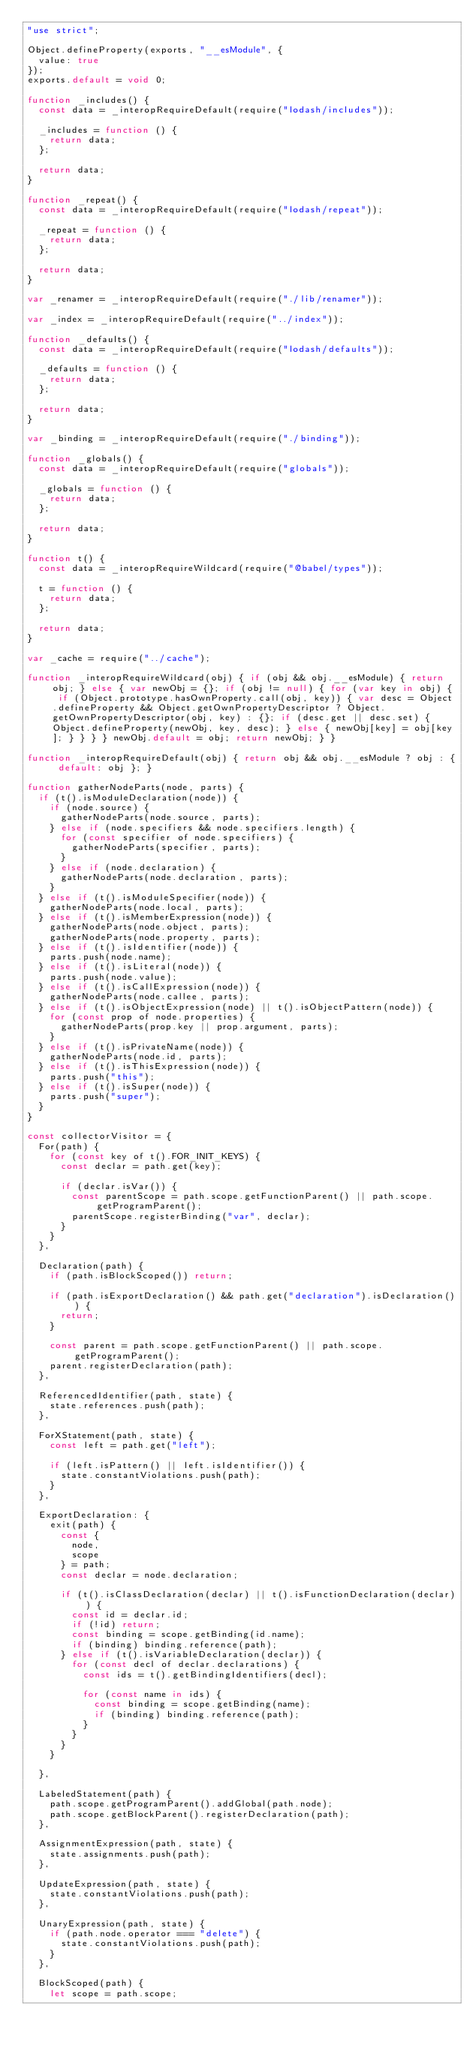Convert code to text. <code><loc_0><loc_0><loc_500><loc_500><_JavaScript_>"use strict";

Object.defineProperty(exports, "__esModule", {
  value: true
});
exports.default = void 0;

function _includes() {
  const data = _interopRequireDefault(require("lodash/includes"));

  _includes = function () {
    return data;
  };

  return data;
}

function _repeat() {
  const data = _interopRequireDefault(require("lodash/repeat"));

  _repeat = function () {
    return data;
  };

  return data;
}

var _renamer = _interopRequireDefault(require("./lib/renamer"));

var _index = _interopRequireDefault(require("../index"));

function _defaults() {
  const data = _interopRequireDefault(require("lodash/defaults"));

  _defaults = function () {
    return data;
  };

  return data;
}

var _binding = _interopRequireDefault(require("./binding"));

function _globals() {
  const data = _interopRequireDefault(require("globals"));

  _globals = function () {
    return data;
  };

  return data;
}

function t() {
  const data = _interopRequireWildcard(require("@babel/types"));

  t = function () {
    return data;
  };

  return data;
}

var _cache = require("../cache");

function _interopRequireWildcard(obj) { if (obj && obj.__esModule) { return obj; } else { var newObj = {}; if (obj != null) { for (var key in obj) { if (Object.prototype.hasOwnProperty.call(obj, key)) { var desc = Object.defineProperty && Object.getOwnPropertyDescriptor ? Object.getOwnPropertyDescriptor(obj, key) : {}; if (desc.get || desc.set) { Object.defineProperty(newObj, key, desc); } else { newObj[key] = obj[key]; } } } } newObj.default = obj; return newObj; } }

function _interopRequireDefault(obj) { return obj && obj.__esModule ? obj : { default: obj }; }

function gatherNodeParts(node, parts) {
  if (t().isModuleDeclaration(node)) {
    if (node.source) {
      gatherNodeParts(node.source, parts);
    } else if (node.specifiers && node.specifiers.length) {
      for (const specifier of node.specifiers) {
        gatherNodeParts(specifier, parts);
      }
    } else if (node.declaration) {
      gatherNodeParts(node.declaration, parts);
    }
  } else if (t().isModuleSpecifier(node)) {
    gatherNodeParts(node.local, parts);
  } else if (t().isMemberExpression(node)) {
    gatherNodeParts(node.object, parts);
    gatherNodeParts(node.property, parts);
  } else if (t().isIdentifier(node)) {
    parts.push(node.name);
  } else if (t().isLiteral(node)) {
    parts.push(node.value);
  } else if (t().isCallExpression(node)) {
    gatherNodeParts(node.callee, parts);
  } else if (t().isObjectExpression(node) || t().isObjectPattern(node)) {
    for (const prop of node.properties) {
      gatherNodeParts(prop.key || prop.argument, parts);
    }
  } else if (t().isPrivateName(node)) {
    gatherNodeParts(node.id, parts);
  } else if (t().isThisExpression(node)) {
    parts.push("this");
  } else if (t().isSuper(node)) {
    parts.push("super");
  }
}

const collectorVisitor = {
  For(path) {
    for (const key of t().FOR_INIT_KEYS) {
      const declar = path.get(key);

      if (declar.isVar()) {
        const parentScope = path.scope.getFunctionParent() || path.scope.getProgramParent();
        parentScope.registerBinding("var", declar);
      }
    }
  },

  Declaration(path) {
    if (path.isBlockScoped()) return;

    if (path.isExportDeclaration() && path.get("declaration").isDeclaration()) {
      return;
    }

    const parent = path.scope.getFunctionParent() || path.scope.getProgramParent();
    parent.registerDeclaration(path);
  },

  ReferencedIdentifier(path, state) {
    state.references.push(path);
  },

  ForXStatement(path, state) {
    const left = path.get("left");

    if (left.isPattern() || left.isIdentifier()) {
      state.constantViolations.push(path);
    }
  },

  ExportDeclaration: {
    exit(path) {
      const {
        node,
        scope
      } = path;
      const declar = node.declaration;

      if (t().isClassDeclaration(declar) || t().isFunctionDeclaration(declar)) {
        const id = declar.id;
        if (!id) return;
        const binding = scope.getBinding(id.name);
        if (binding) binding.reference(path);
      } else if (t().isVariableDeclaration(declar)) {
        for (const decl of declar.declarations) {
          const ids = t().getBindingIdentifiers(decl);

          for (const name in ids) {
            const binding = scope.getBinding(name);
            if (binding) binding.reference(path);
          }
        }
      }
    }

  },

  LabeledStatement(path) {
    path.scope.getProgramParent().addGlobal(path.node);
    path.scope.getBlockParent().registerDeclaration(path);
  },

  AssignmentExpression(path, state) {
    state.assignments.push(path);
  },

  UpdateExpression(path, state) {
    state.constantViolations.push(path);
  },

  UnaryExpression(path, state) {
    if (path.node.operator === "delete") {
      state.constantViolations.push(path);
    }
  },

  BlockScoped(path) {
    let scope = path.scope;</code> 